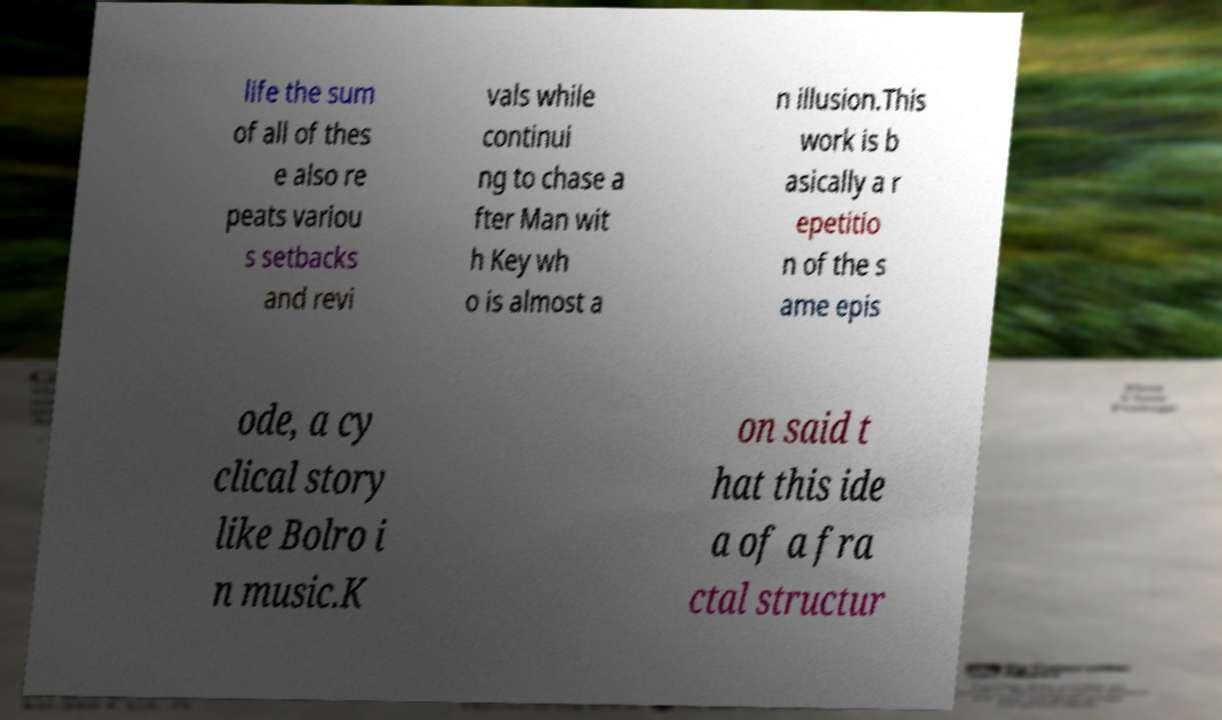Could you assist in decoding the text presented in this image and type it out clearly? life the sum of all of thes e also re peats variou s setbacks and revi vals while continui ng to chase a fter Man wit h Key wh o is almost a n illusion.This work is b asically a r epetitio n of the s ame epis ode, a cy clical story like Bolro i n music.K on said t hat this ide a of a fra ctal structur 